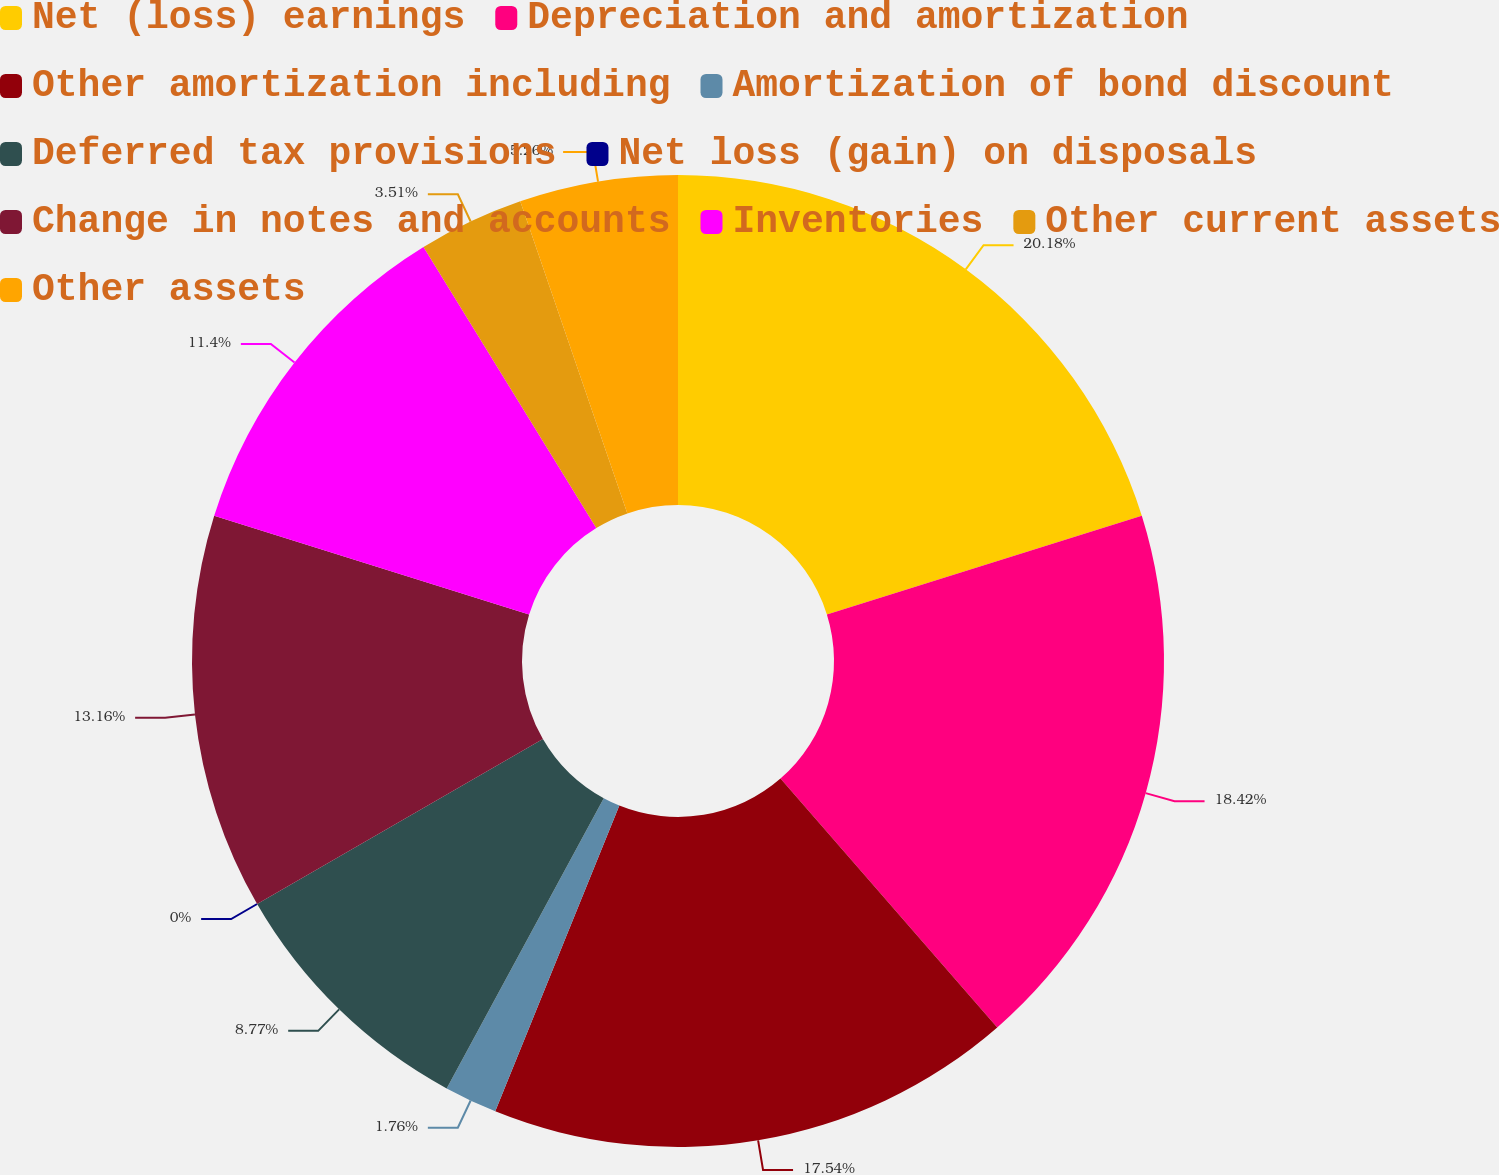Convert chart. <chart><loc_0><loc_0><loc_500><loc_500><pie_chart><fcel>Net (loss) earnings<fcel>Depreciation and amortization<fcel>Other amortization including<fcel>Amortization of bond discount<fcel>Deferred tax provisions<fcel>Net loss (gain) on disposals<fcel>Change in notes and accounts<fcel>Inventories<fcel>Other current assets<fcel>Other assets<nl><fcel>20.17%<fcel>18.42%<fcel>17.54%<fcel>1.76%<fcel>8.77%<fcel>0.0%<fcel>13.16%<fcel>11.4%<fcel>3.51%<fcel>5.26%<nl></chart> 